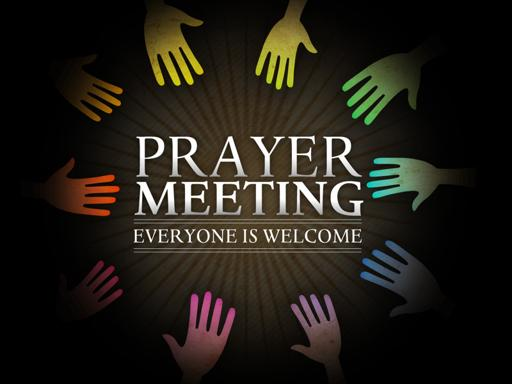What is the main message of the text in the image? The central theme of the text in the image is to announce a prayer meeting emphasizing that it is an inclusive event, welcoming everyone regardless of their background. This openness fosters a sense of community and mutual respect among attendees. 